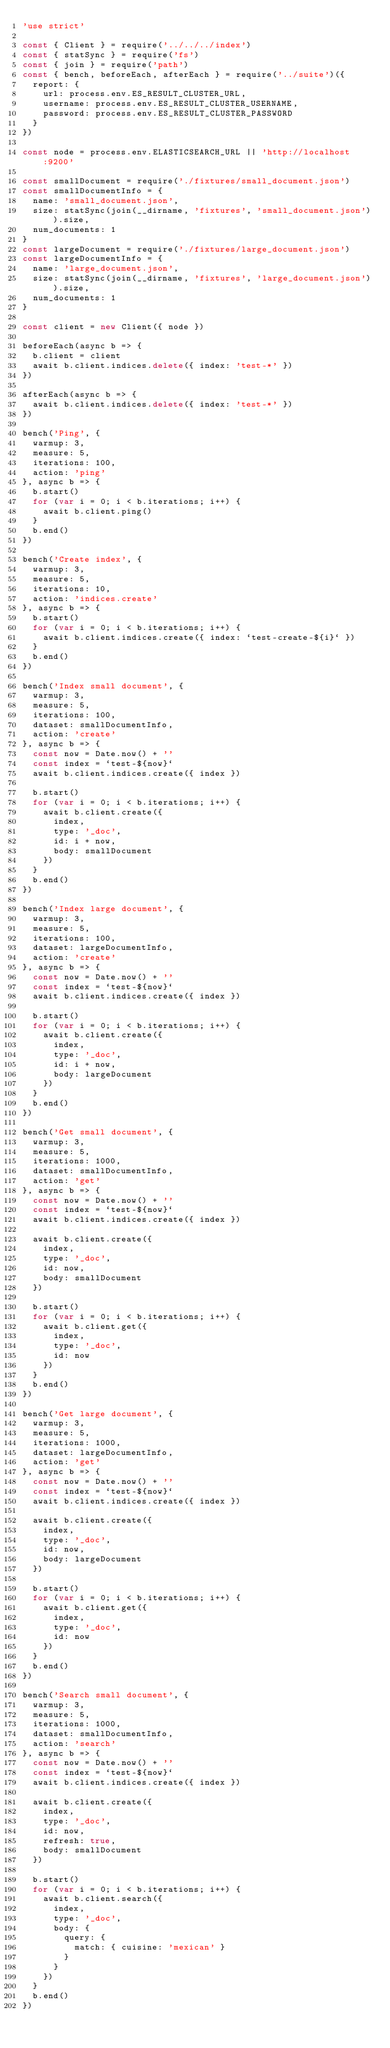Convert code to text. <code><loc_0><loc_0><loc_500><loc_500><_JavaScript_>'use strict'

const { Client } = require('../../../index')
const { statSync } = require('fs')
const { join } = require('path')
const { bench, beforeEach, afterEach } = require('../suite')({
  report: {
    url: process.env.ES_RESULT_CLUSTER_URL,
    username: process.env.ES_RESULT_CLUSTER_USERNAME,
    password: process.env.ES_RESULT_CLUSTER_PASSWORD
  }
})

const node = process.env.ELASTICSEARCH_URL || 'http://localhost:9200'

const smallDocument = require('./fixtures/small_document.json')
const smallDocumentInfo = {
  name: 'small_document.json',
  size: statSync(join(__dirname, 'fixtures', 'small_document.json')).size,
  num_documents: 1
}
const largeDocument = require('./fixtures/large_document.json')
const largeDocumentInfo = {
  name: 'large_document.json',
  size: statSync(join(__dirname, 'fixtures', 'large_document.json')).size,
  num_documents: 1
}

const client = new Client({ node })

beforeEach(async b => {
  b.client = client
  await b.client.indices.delete({ index: 'test-*' })
})

afterEach(async b => {
  await b.client.indices.delete({ index: 'test-*' })
})

bench('Ping', {
  warmup: 3,
  measure: 5,
  iterations: 100,
  action: 'ping'
}, async b => {
  b.start()
  for (var i = 0; i < b.iterations; i++) {
    await b.client.ping()
  }
  b.end()
})

bench('Create index', {
  warmup: 3,
  measure: 5,
  iterations: 10,
  action: 'indices.create'
}, async b => {
  b.start()
  for (var i = 0; i < b.iterations; i++) {
    await b.client.indices.create({ index: `test-create-${i}` })
  }
  b.end()
})

bench('Index small document', {
  warmup: 3,
  measure: 5,
  iterations: 100,
  dataset: smallDocumentInfo,
  action: 'create'
}, async b => {
  const now = Date.now() + ''
  const index = `test-${now}`
  await b.client.indices.create({ index })

  b.start()
  for (var i = 0; i < b.iterations; i++) {
    await b.client.create({
      index,
      type: '_doc',
      id: i + now,
      body: smallDocument
    })
  }
  b.end()
})

bench('Index large document', {
  warmup: 3,
  measure: 5,
  iterations: 100,
  dataset: largeDocumentInfo,
  action: 'create'
}, async b => {
  const now = Date.now() + ''
  const index = `test-${now}`
  await b.client.indices.create({ index })

  b.start()
  for (var i = 0; i < b.iterations; i++) {
    await b.client.create({
      index,
      type: '_doc',
      id: i + now,
      body: largeDocument
    })
  }
  b.end()
})

bench('Get small document', {
  warmup: 3,
  measure: 5,
  iterations: 1000,
  dataset: smallDocumentInfo,
  action: 'get'
}, async b => {
  const now = Date.now() + ''
  const index = `test-${now}`
  await b.client.indices.create({ index })

  await b.client.create({
    index,
    type: '_doc',
    id: now,
    body: smallDocument
  })

  b.start()
  for (var i = 0; i < b.iterations; i++) {
    await b.client.get({
      index,
      type: '_doc',
      id: now
    })
  }
  b.end()
})

bench('Get large document', {
  warmup: 3,
  measure: 5,
  iterations: 1000,
  dataset: largeDocumentInfo,
  action: 'get'
}, async b => {
  const now = Date.now() + ''
  const index = `test-${now}`
  await b.client.indices.create({ index })

  await b.client.create({
    index,
    type: '_doc',
    id: now,
    body: largeDocument
  })

  b.start()
  for (var i = 0; i < b.iterations; i++) {
    await b.client.get({
      index,
      type: '_doc',
      id: now
    })
  }
  b.end()
})

bench('Search small document', {
  warmup: 3,
  measure: 5,
  iterations: 1000,
  dataset: smallDocumentInfo,
  action: 'search'
}, async b => {
  const now = Date.now() + ''
  const index = `test-${now}`
  await b.client.indices.create({ index })

  await b.client.create({
    index,
    type: '_doc',
    id: now,
    refresh: true,
    body: smallDocument
  })

  b.start()
  for (var i = 0; i < b.iterations; i++) {
    await b.client.search({
      index,
      type: '_doc',
      body: {
        query: {
          match: { cuisine: 'mexican' }
        }
      }
    })
  }
  b.end()
})
</code> 